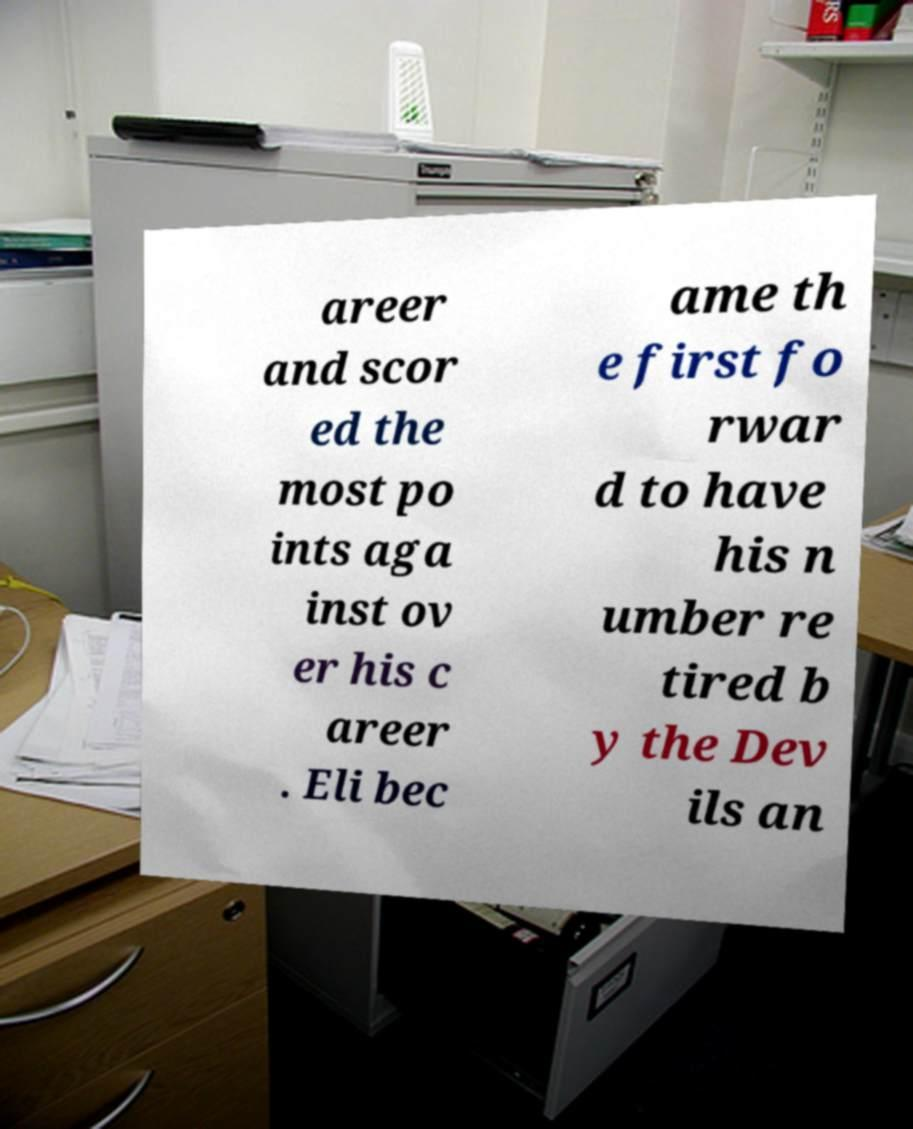Can you read and provide the text displayed in the image?This photo seems to have some interesting text. Can you extract and type it out for me? areer and scor ed the most po ints aga inst ov er his c areer . Eli bec ame th e first fo rwar d to have his n umber re tired b y the Dev ils an 